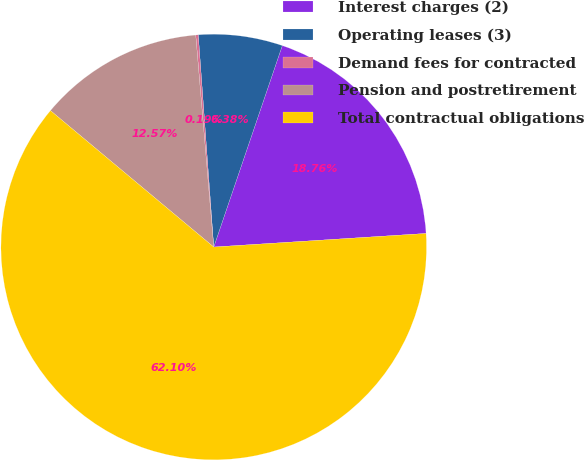<chart> <loc_0><loc_0><loc_500><loc_500><pie_chart><fcel>Interest charges (2)<fcel>Operating leases (3)<fcel>Demand fees for contracted<fcel>Pension and postretirement<fcel>Total contractual obligations<nl><fcel>18.76%<fcel>6.38%<fcel>0.19%<fcel>12.57%<fcel>62.09%<nl></chart> 